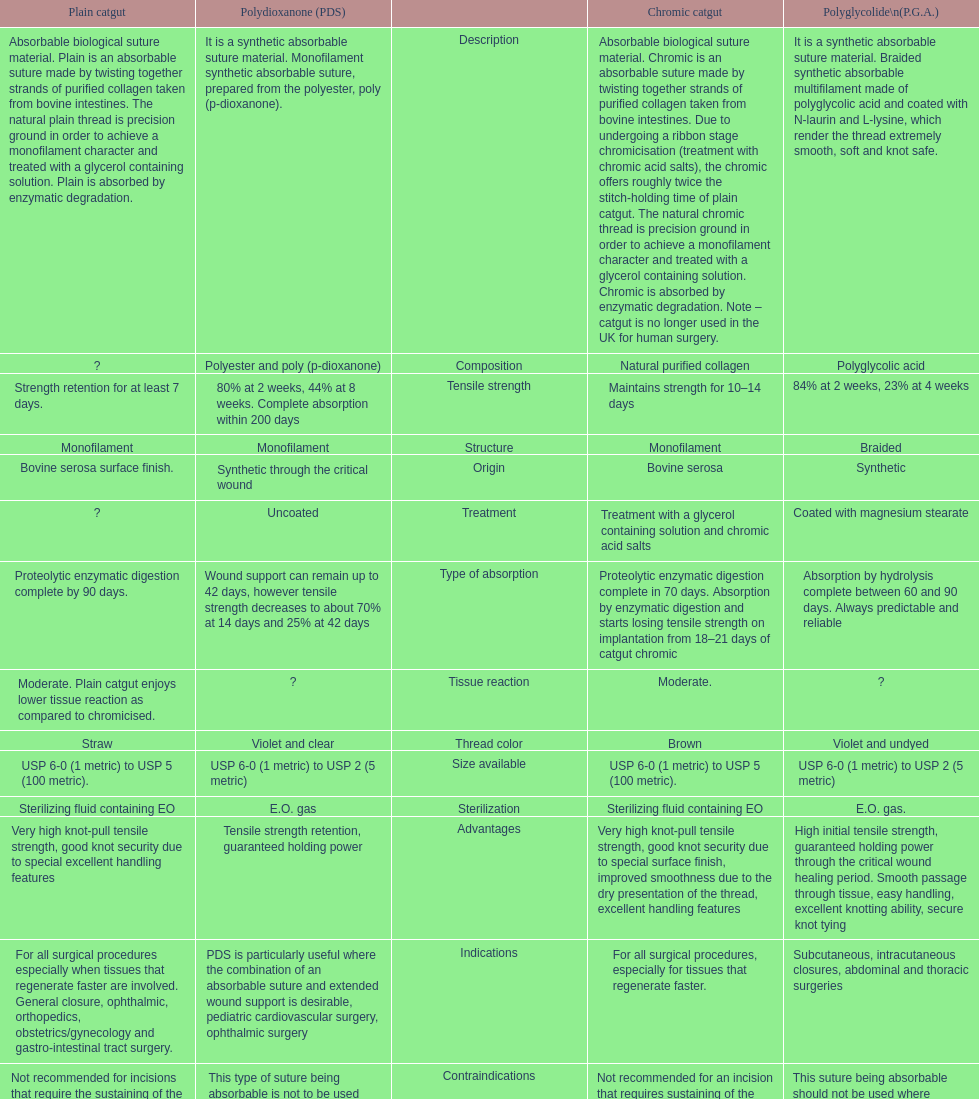The basic catgut sustains its sturdiness for no less than how many days? Strength retention for at least 7 days. 